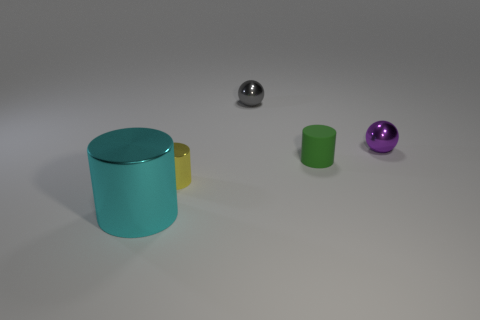Is the number of tiny rubber cylinders left of the big shiny cylinder greater than the number of tiny purple objects?
Keep it short and to the point. No. What is the material of the tiny sphere that is to the left of the tiny object that is on the right side of the cylinder that is right of the small yellow metal object?
Your response must be concise. Metal. How many objects are either large green cylinders or small cylinders right of the yellow cylinder?
Ensure brevity in your answer.  1. There is a metal cylinder to the right of the cyan metal cylinder; is it the same color as the tiny matte thing?
Your answer should be very brief. No. Is the number of cyan objects in front of the cyan object greater than the number of yellow shiny objects that are behind the tiny purple metallic object?
Your response must be concise. No. Is there any other thing that is the same color as the big thing?
Provide a short and direct response. No. What number of objects are large metal objects or small gray rubber objects?
Offer a very short reply. 1. Do the metallic object that is to the right of the green cylinder and the cyan cylinder have the same size?
Keep it short and to the point. No. How many other objects are the same size as the purple metallic thing?
Provide a short and direct response. 3. Is there a big shiny thing?
Offer a terse response. Yes. 